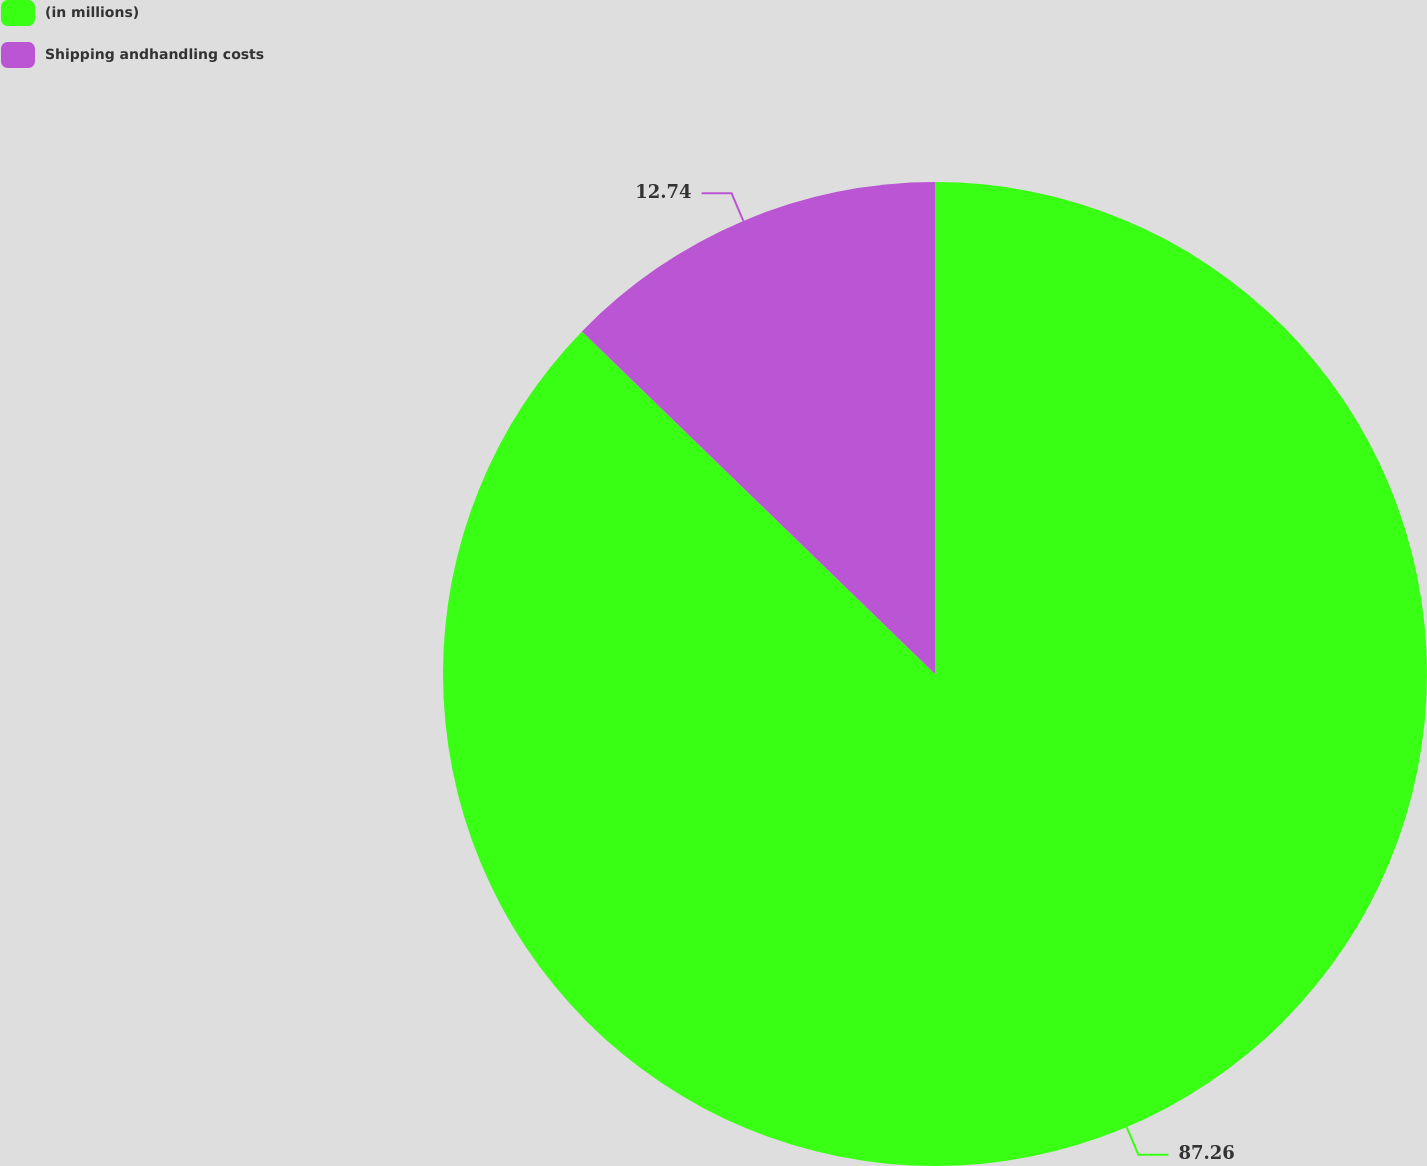Convert chart. <chart><loc_0><loc_0><loc_500><loc_500><pie_chart><fcel>(in millions)<fcel>Shipping andhandling costs<nl><fcel>87.26%<fcel>12.74%<nl></chart> 